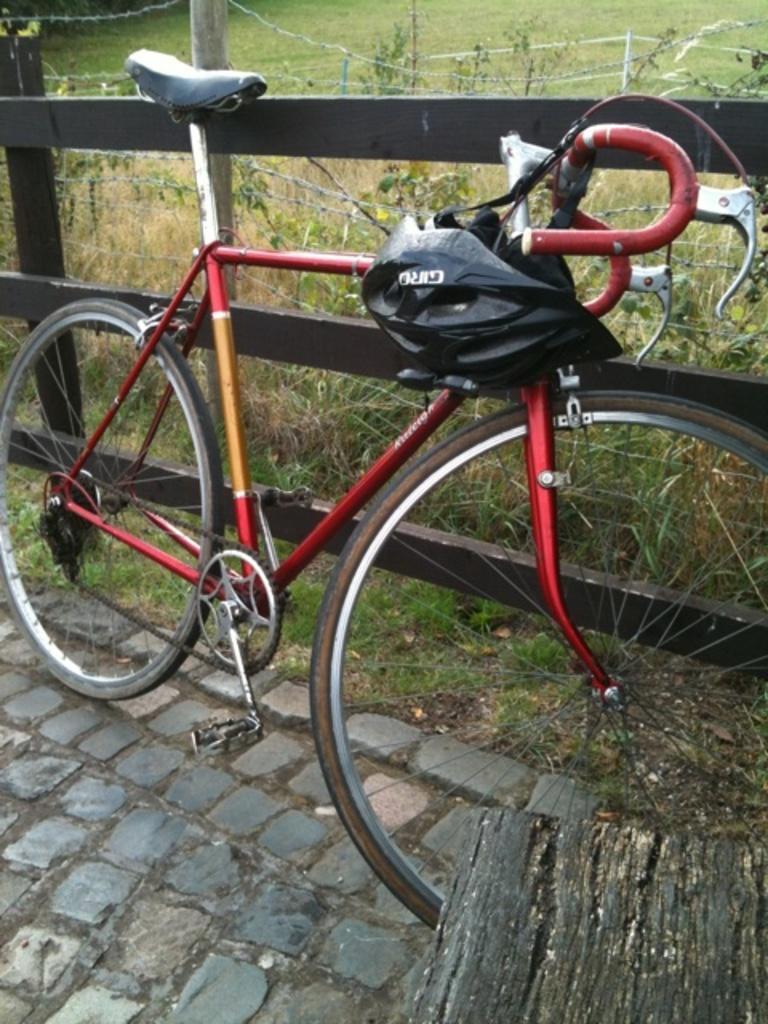Can you describe this image briefly? In the image in the center, we can see one cycle and helmet. In the background there is a fence, grass and plants. 